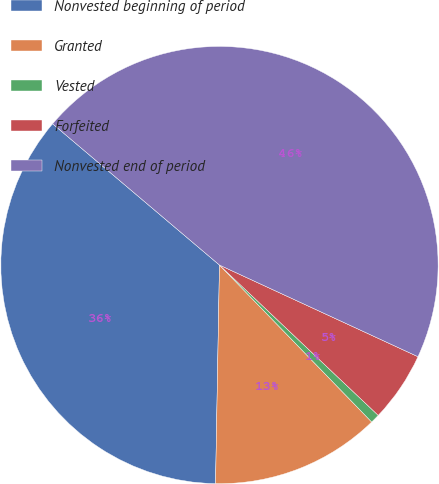<chart> <loc_0><loc_0><loc_500><loc_500><pie_chart><fcel>Nonvested beginning of period<fcel>Granted<fcel>Vested<fcel>Forfeited<fcel>Nonvested end of period<nl><fcel>35.89%<fcel>12.54%<fcel>0.68%<fcel>5.18%<fcel>45.7%<nl></chart> 